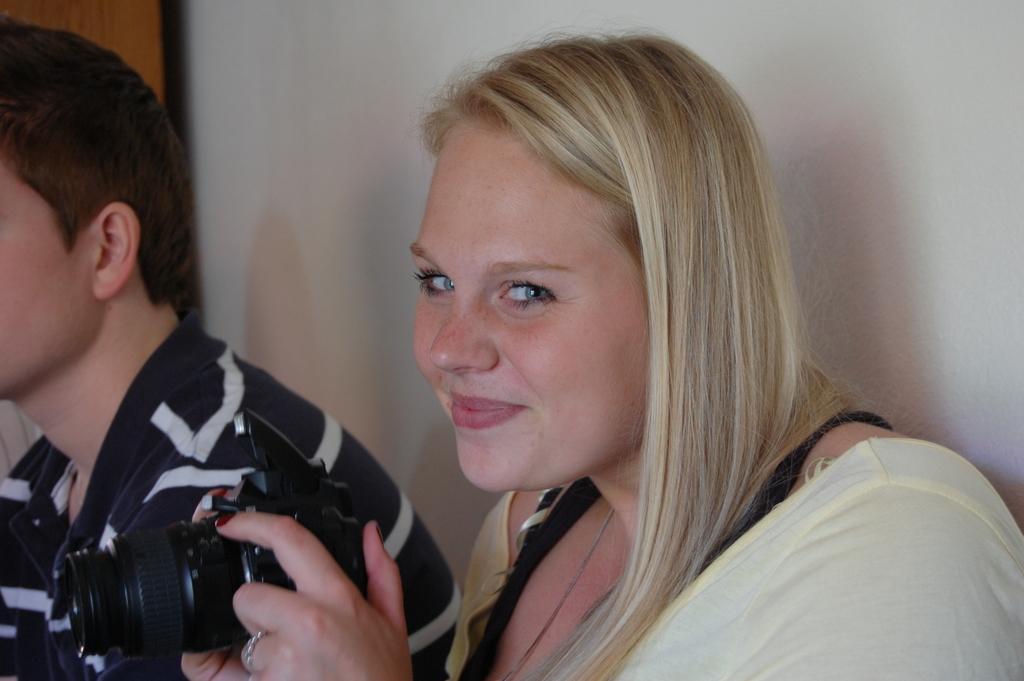Can you describe this image briefly? In this image on the right side there is one woman who is holding a camera and she is smiling, beside her there is one man and on the background there is a wall. 